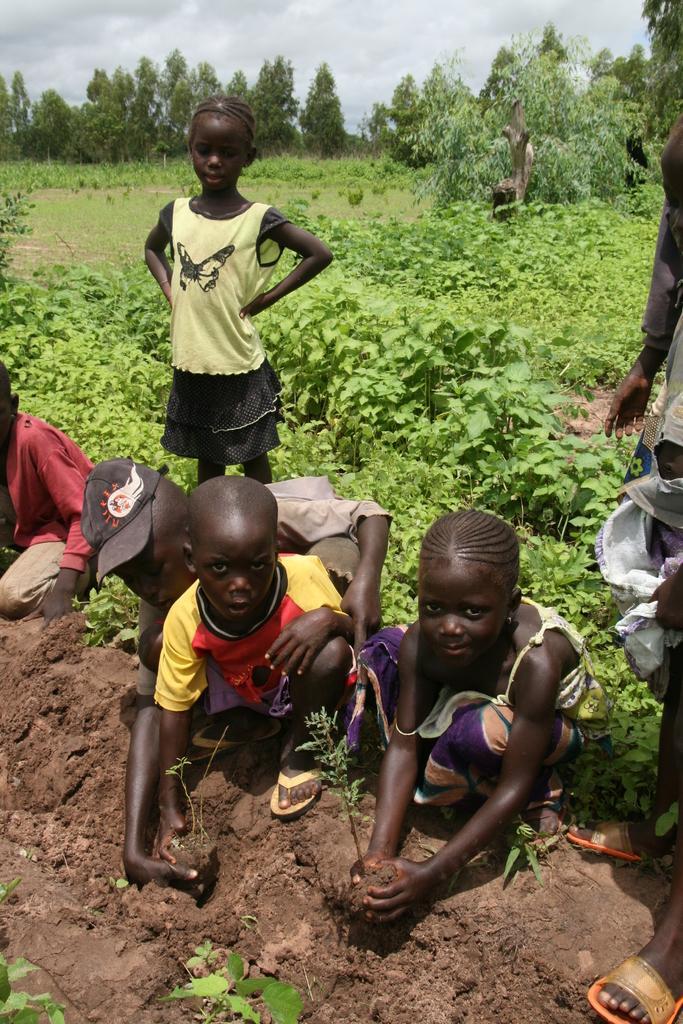Describe this image in one or two sentences. In the middle of the image few kids are standing and sitting. Behind them we can see some plants and trees. At the bottom of the image we can see sand. At the top of the image we can see some clouds in the sky. 